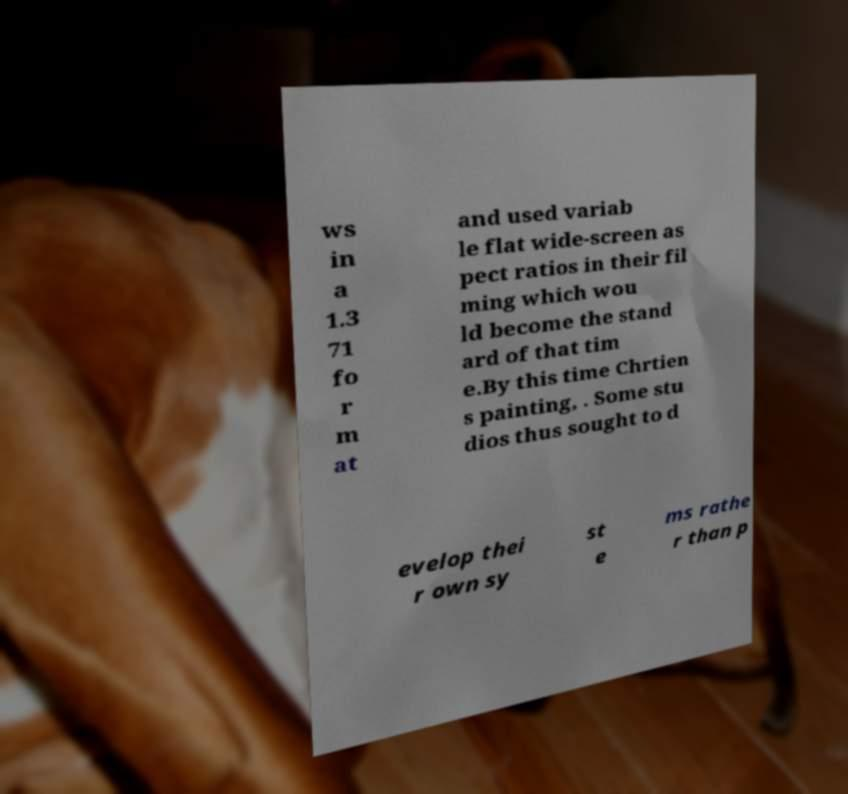Please identify and transcribe the text found in this image. ws in a 1.3 71 fo r m at and used variab le flat wide-screen as pect ratios in their fil ming which wou ld become the stand ard of that tim e.By this time Chrtien s painting, . Some stu dios thus sought to d evelop thei r own sy st e ms rathe r than p 